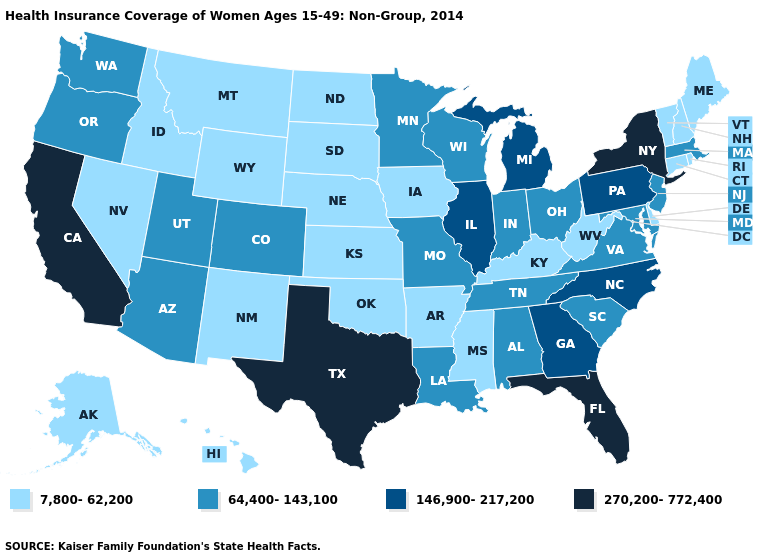Does Florida have the highest value in the South?
Give a very brief answer. Yes. What is the highest value in the USA?
Write a very short answer. 270,200-772,400. Does the first symbol in the legend represent the smallest category?
Answer briefly. Yes. Does New Hampshire have the lowest value in the USA?
Short answer required. Yes. Does Texas have a higher value than California?
Short answer required. No. Is the legend a continuous bar?
Answer briefly. No. Name the states that have a value in the range 146,900-217,200?
Write a very short answer. Georgia, Illinois, Michigan, North Carolina, Pennsylvania. What is the value of Nebraska?
Short answer required. 7,800-62,200. What is the value of Kentucky?
Quick response, please. 7,800-62,200. Does Mississippi have the highest value in the USA?
Short answer required. No. What is the value of Virginia?
Write a very short answer. 64,400-143,100. Name the states that have a value in the range 7,800-62,200?
Be succinct. Alaska, Arkansas, Connecticut, Delaware, Hawaii, Idaho, Iowa, Kansas, Kentucky, Maine, Mississippi, Montana, Nebraska, Nevada, New Hampshire, New Mexico, North Dakota, Oklahoma, Rhode Island, South Dakota, Vermont, West Virginia, Wyoming. What is the value of Massachusetts?
Quick response, please. 64,400-143,100. How many symbols are there in the legend?
Concise answer only. 4. What is the value of Minnesota?
Quick response, please. 64,400-143,100. 